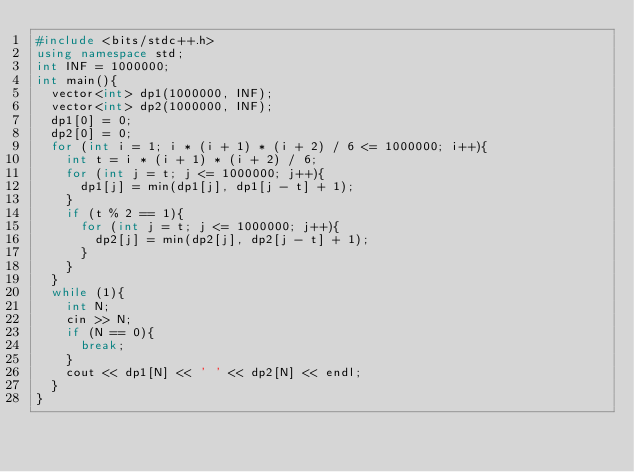<code> <loc_0><loc_0><loc_500><loc_500><_C++_>#include <bits/stdc++.h>
using namespace std;
int INF = 1000000;
int main(){
  vector<int> dp1(1000000, INF);
  vector<int> dp2(1000000, INF);
  dp1[0] = 0;
  dp2[0] = 0;
  for (int i = 1; i * (i + 1) * (i + 2) / 6 <= 1000000; i++){
    int t = i * (i + 1) * (i + 2) / 6;
    for (int j = t; j <= 1000000; j++){
      dp1[j] = min(dp1[j], dp1[j - t] + 1);
    }
    if (t % 2 == 1){
      for (int j = t; j <= 1000000; j++){
        dp2[j] = min(dp2[j], dp2[j - t] + 1);
      }
    }
  }
  while (1){
    int N;
    cin >> N;
    if (N == 0){
      break;
    }
    cout << dp1[N] << ' ' << dp2[N] << endl;
  }
}
</code> 